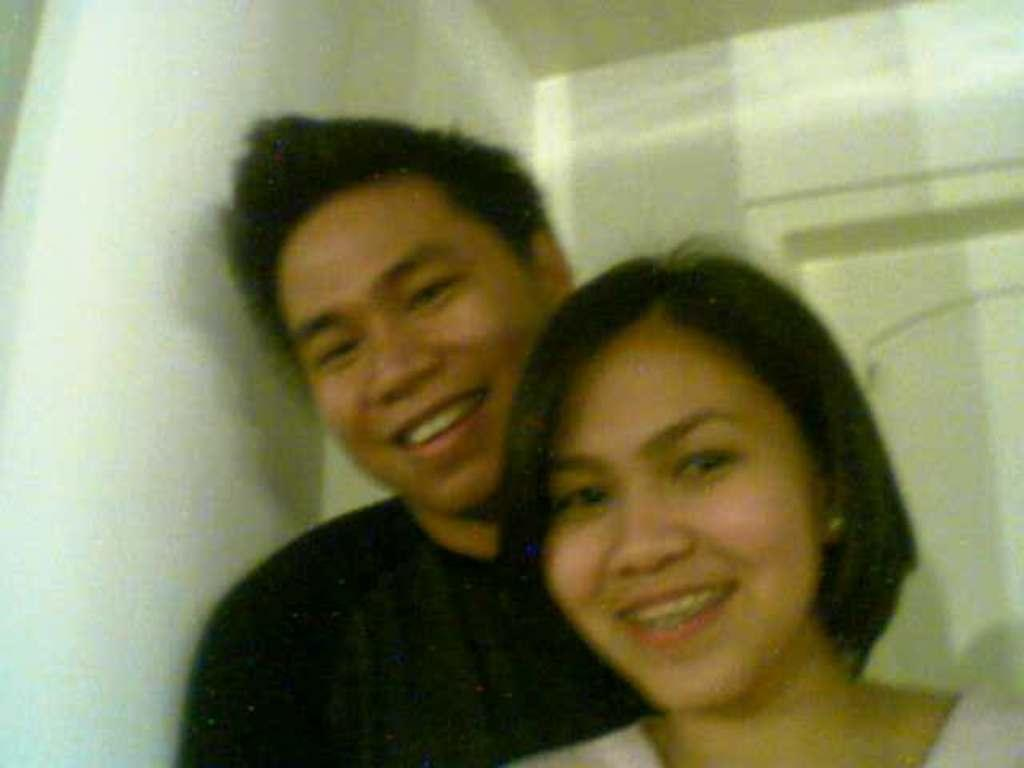How many people are in the image? There are two persons in the image. What is the woman wearing? The woman is wearing a white dress. What is the man wearing? The man is wearing a black T-shirt. What can be seen in the background of the image? There is a wall and a door in the background of the image. What type of corn is the man holding in the image? There is no corn present in the image; the man is wearing a black T-shirt. How many legs does the woman have in the image? The woman has two legs in the image, but this question is irrelevant as the number of legs is not a relevant detail in the context of the image. 